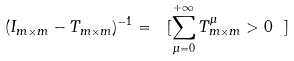<formula> <loc_0><loc_0><loc_500><loc_500>( I _ { m \times m } - T _ { m \times m } ) ^ { - 1 } = \ [ \sum _ { \mu = 0 } ^ { + \infty } T _ { m \times m } ^ { \mu } > 0 \ ]</formula> 